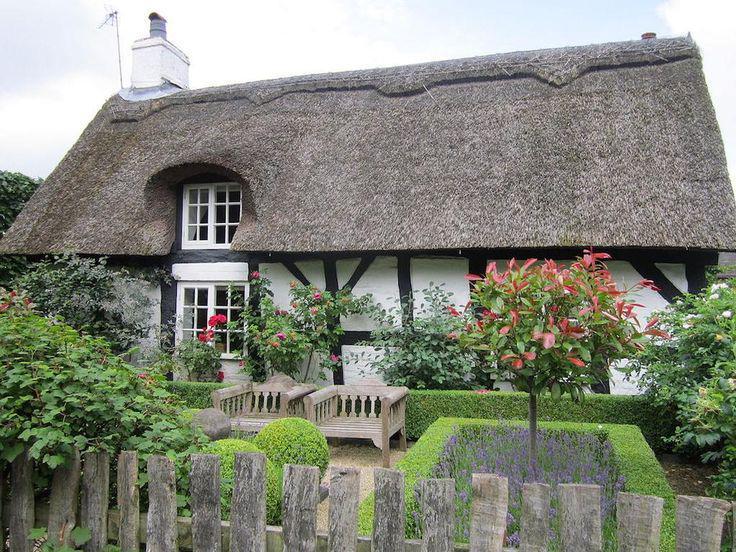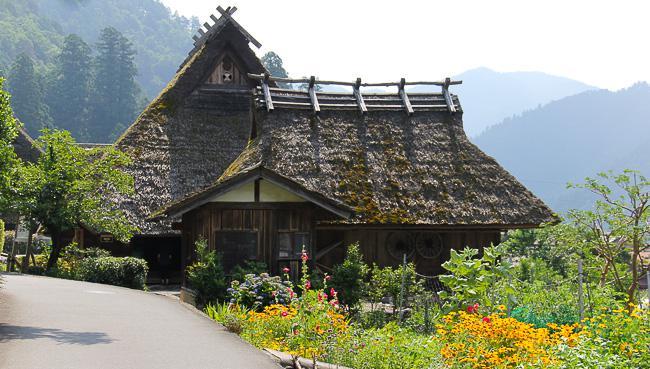The first image is the image on the left, the second image is the image on the right. Given the left and right images, does the statement "In the left image, a picket fence is in front of a house with paned windows and a thick grayish roof with at least one notch to accommodate an upper story window." hold true? Answer yes or no. Yes. The first image is the image on the left, the second image is the image on the right. Analyze the images presented: Is the assertion "There is a thatched roof cottage that has a picket fence." valid? Answer yes or no. Yes. 